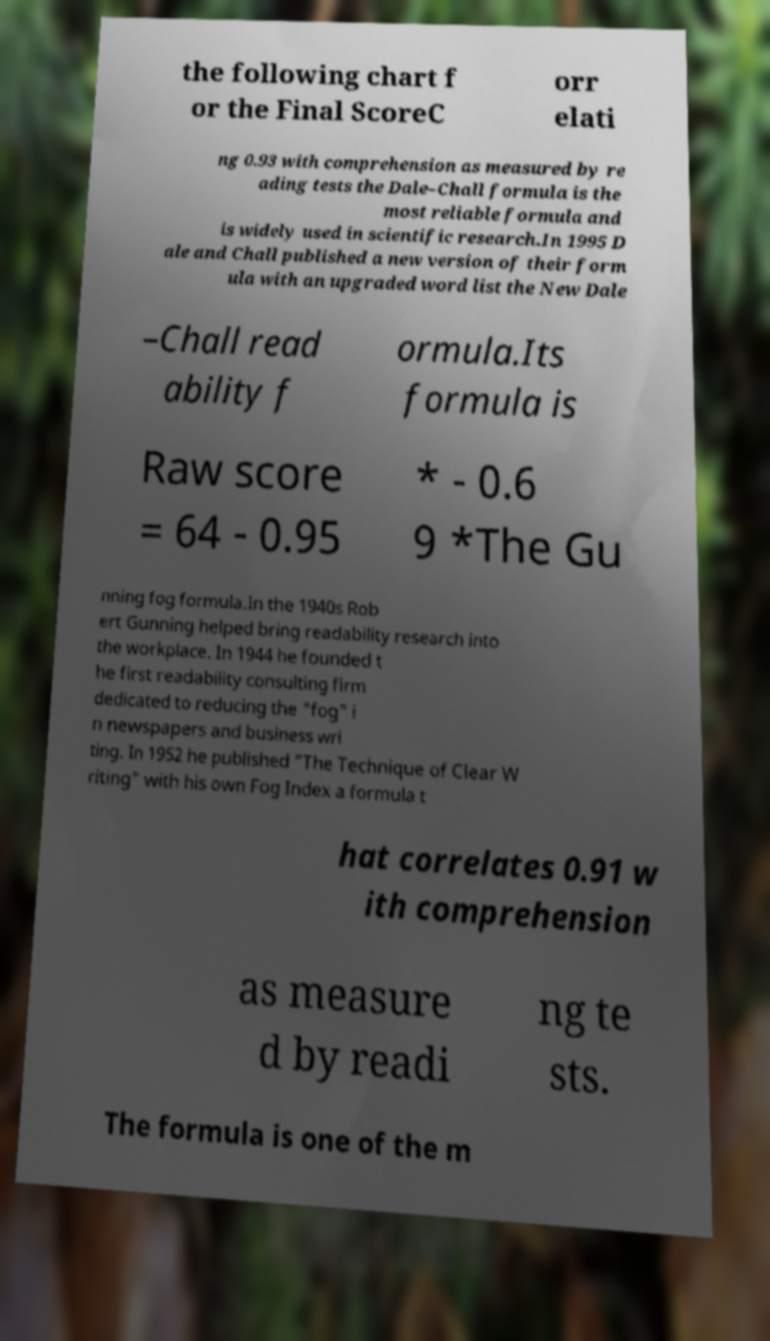Please identify and transcribe the text found in this image. the following chart f or the Final ScoreC orr elati ng 0.93 with comprehension as measured by re ading tests the Dale–Chall formula is the most reliable formula and is widely used in scientific research.In 1995 D ale and Chall published a new version of their form ula with an upgraded word list the New Dale –Chall read ability f ormula.Its formula is Raw score = 64 - 0.95 * - 0.6 9 *The Gu nning fog formula.In the 1940s Rob ert Gunning helped bring readability research into the workplace. In 1944 he founded t he first readability consulting firm dedicated to reducing the "fog" i n newspapers and business wri ting. In 1952 he published "The Technique of Clear W riting" with his own Fog Index a formula t hat correlates 0.91 w ith comprehension as measure d by readi ng te sts. The formula is one of the m 